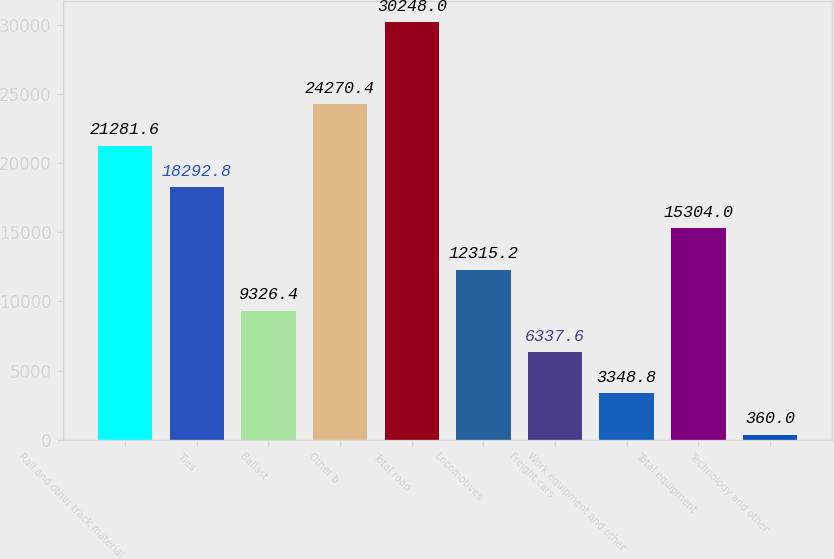Convert chart. <chart><loc_0><loc_0><loc_500><loc_500><bar_chart><fcel>Rail and other track material<fcel>Ties<fcel>Ballast<fcel>Other b<fcel>Total road<fcel>Locomotives<fcel>Freight cars<fcel>Work equipment and other<fcel>Total equipment<fcel>Technology and other<nl><fcel>21281.6<fcel>18292.8<fcel>9326.4<fcel>24270.4<fcel>30248<fcel>12315.2<fcel>6337.6<fcel>3348.8<fcel>15304<fcel>360<nl></chart> 